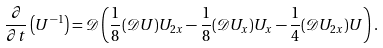Convert formula to latex. <formula><loc_0><loc_0><loc_500><loc_500>\frac { \partial } { \partial t } \left ( U ^ { - 1 } \right ) = \mathcal { D } \left ( \frac { 1 } { 8 } ( \mathcal { D } U ) U _ { 2 x } - \frac { 1 } { 8 } ( \mathcal { D } U _ { x } ) U _ { x } - \frac { 1 } { 4 } ( \mathcal { D } U _ { 2 x } ) U \right ) .</formula> 